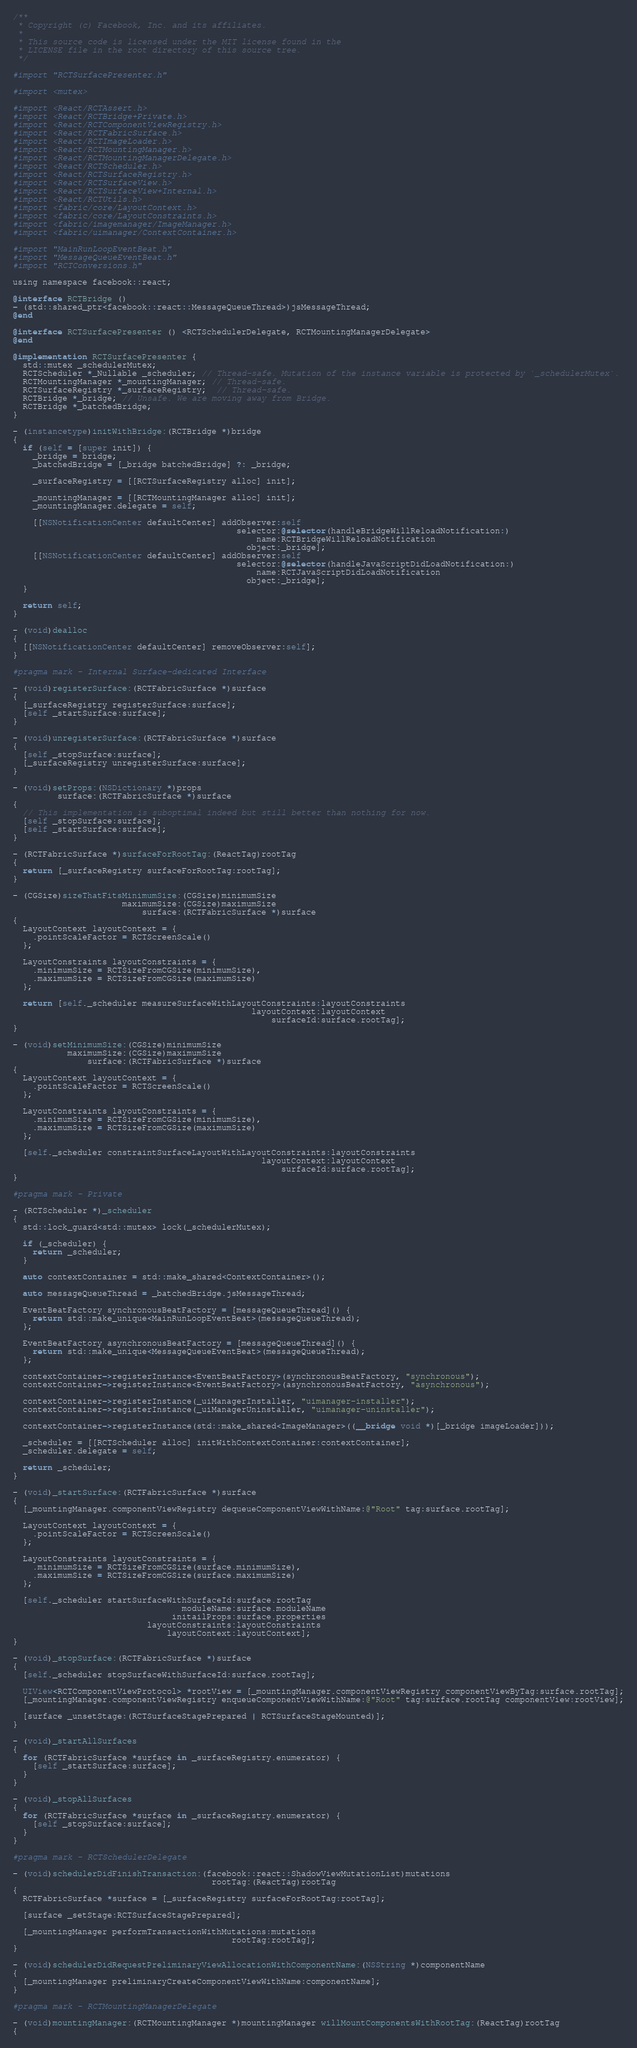Convert code to text. <code><loc_0><loc_0><loc_500><loc_500><_ObjectiveC_>/**
 * Copyright (c) Facebook, Inc. and its affiliates.
 *
 * This source code is licensed under the MIT license found in the
 * LICENSE file in the root directory of this source tree.
 */

#import "RCTSurfacePresenter.h"

#import <mutex>

#import <React/RCTAssert.h>
#import <React/RCTBridge+Private.h>
#import <React/RCTComponentViewRegistry.h>
#import <React/RCTFabricSurface.h>
#import <React/RCTImageLoader.h>
#import <React/RCTMountingManager.h>
#import <React/RCTMountingManagerDelegate.h>
#import <React/RCTScheduler.h>
#import <React/RCTSurfaceRegistry.h>
#import <React/RCTSurfaceView.h>
#import <React/RCTSurfaceView+Internal.h>
#import <React/RCTUtils.h>
#import <fabric/core/LayoutContext.h>
#import <fabric/core/LayoutConstraints.h>
#import <fabric/imagemanager/ImageManager.h>
#import <fabric/uimanager/ContextContainer.h>

#import "MainRunLoopEventBeat.h"
#import "MessageQueueEventBeat.h"
#import "RCTConversions.h"

using namespace facebook::react;

@interface RCTBridge ()
- (std::shared_ptr<facebook::react::MessageQueueThread>)jsMessageThread;
@end

@interface RCTSurfacePresenter () <RCTSchedulerDelegate, RCTMountingManagerDelegate>
@end

@implementation RCTSurfacePresenter {
  std::mutex _schedulerMutex;
  RCTScheduler *_Nullable _scheduler; // Thread-safe. Mutation of the instance variable is protected by `_schedulerMutex`.
  RCTMountingManager *_mountingManager; // Thread-safe.
  RCTSurfaceRegistry *_surfaceRegistry;  // Thread-safe.
  RCTBridge *_bridge; // Unsafe. We are moving away from Bridge.
  RCTBridge *_batchedBridge;
}

- (instancetype)initWithBridge:(RCTBridge *)bridge
{
  if (self = [super init]) {
    _bridge = bridge;
    _batchedBridge = [_bridge batchedBridge] ?: _bridge;

    _surfaceRegistry = [[RCTSurfaceRegistry alloc] init];

    _mountingManager = [[RCTMountingManager alloc] init];
    _mountingManager.delegate = self;

    [[NSNotificationCenter defaultCenter] addObserver:self
                                             selector:@selector(handleBridgeWillReloadNotification:)
                                                 name:RCTBridgeWillReloadNotification
                                               object:_bridge];
    [[NSNotificationCenter defaultCenter] addObserver:self
                                             selector:@selector(handleJavaScriptDidLoadNotification:)
                                                 name:RCTJavaScriptDidLoadNotification
                                               object:_bridge];
  }

  return self;
}

- (void)dealloc
{
  [[NSNotificationCenter defaultCenter] removeObserver:self];
}

#pragma mark - Internal Surface-dedicated Interface

- (void)registerSurface:(RCTFabricSurface *)surface
{
  [_surfaceRegistry registerSurface:surface];
  [self _startSurface:surface];
}

- (void)unregisterSurface:(RCTFabricSurface *)surface
{
  [self _stopSurface:surface];
  [_surfaceRegistry unregisterSurface:surface];
}

- (void)setProps:(NSDictionary *)props
         surface:(RCTFabricSurface *)surface
{
  // This implementation is suboptimal indeed but still better than nothing for now.
  [self _stopSurface:surface];
  [self _startSurface:surface];
}

- (RCTFabricSurface *)surfaceForRootTag:(ReactTag)rootTag
{
  return [_surfaceRegistry surfaceForRootTag:rootTag];
}

- (CGSize)sizeThatFitsMinimumSize:(CGSize)minimumSize
                      maximumSize:(CGSize)maximumSize
                          surface:(RCTFabricSurface *)surface
{
  LayoutContext layoutContext = {
    .pointScaleFactor = RCTScreenScale()
  };

  LayoutConstraints layoutConstraints = {
    .minimumSize = RCTSizeFromCGSize(minimumSize),
    .maximumSize = RCTSizeFromCGSize(maximumSize)
  };

  return [self._scheduler measureSurfaceWithLayoutConstraints:layoutConstraints
                                                layoutContext:layoutContext
                                                    surfaceId:surface.rootTag];
}

- (void)setMinimumSize:(CGSize)minimumSize
           maximumSize:(CGSize)maximumSize
               surface:(RCTFabricSurface *)surface
{
  LayoutContext layoutContext = {
    .pointScaleFactor = RCTScreenScale()
  };

  LayoutConstraints layoutConstraints = {
    .minimumSize = RCTSizeFromCGSize(minimumSize),
    .maximumSize = RCTSizeFromCGSize(maximumSize)
  };

  [self._scheduler constraintSurfaceLayoutWithLayoutConstraints:layoutConstraints
                                                  layoutContext:layoutContext
                                                      surfaceId:surface.rootTag];
}

#pragma mark - Private

- (RCTScheduler *)_scheduler
{
  std::lock_guard<std::mutex> lock(_schedulerMutex);

  if (_scheduler) {
    return _scheduler;
  }

  auto contextContainer = std::make_shared<ContextContainer>();

  auto messageQueueThread = _batchedBridge.jsMessageThread;

  EventBeatFactory synchronousBeatFactory = [messageQueueThread]() {
    return std::make_unique<MainRunLoopEventBeat>(messageQueueThread);
  };

  EventBeatFactory asynchronousBeatFactory = [messageQueueThread]() {
    return std::make_unique<MessageQueueEventBeat>(messageQueueThread);
  };

  contextContainer->registerInstance<EventBeatFactory>(synchronousBeatFactory, "synchronous");
  contextContainer->registerInstance<EventBeatFactory>(asynchronousBeatFactory, "asynchronous");

  contextContainer->registerInstance(_uiManagerInstaller, "uimanager-installer");
  contextContainer->registerInstance(_uiManagerUninstaller, "uimanager-uninstaller");

  contextContainer->registerInstance(std::make_shared<ImageManager>((__bridge void *)[_bridge imageLoader]));

  _scheduler = [[RCTScheduler alloc] initWithContextContainer:contextContainer];
  _scheduler.delegate = self;

  return _scheduler;
}

- (void)_startSurface:(RCTFabricSurface *)surface
{
  [_mountingManager.componentViewRegistry dequeueComponentViewWithName:@"Root" tag:surface.rootTag];

  LayoutContext layoutContext = {
    .pointScaleFactor = RCTScreenScale()
  };

  LayoutConstraints layoutConstraints = {
    .minimumSize = RCTSizeFromCGSize(surface.minimumSize),
    .maximumSize = RCTSizeFromCGSize(surface.maximumSize)
  };

  [self._scheduler startSurfaceWithSurfaceId:surface.rootTag
                                  moduleName:surface.moduleName
                                initailProps:surface.properties
                           layoutConstraints:layoutConstraints
                               layoutContext:layoutContext];
}

- (void)_stopSurface:(RCTFabricSurface *)surface
{
  [self._scheduler stopSurfaceWithSurfaceId:surface.rootTag];

  UIView<RCTComponentViewProtocol> *rootView = [_mountingManager.componentViewRegistry componentViewByTag:surface.rootTag];
  [_mountingManager.componentViewRegistry enqueueComponentViewWithName:@"Root" tag:surface.rootTag componentView:rootView];

  [surface _unsetStage:(RCTSurfaceStagePrepared | RCTSurfaceStageMounted)];
}

- (void)_startAllSurfaces
{
  for (RCTFabricSurface *surface in _surfaceRegistry.enumerator) {
    [self _startSurface:surface];
  }
}

- (void)_stopAllSurfaces
{
  for (RCTFabricSurface *surface in _surfaceRegistry.enumerator) {
    [self _stopSurface:surface];
  }
}

#pragma mark - RCTSchedulerDelegate

- (void)schedulerDidFinishTransaction:(facebook::react::ShadowViewMutationList)mutations
                                        rootTag:(ReactTag)rootTag
{
  RCTFabricSurface *surface = [_surfaceRegistry surfaceForRootTag:rootTag];

  [surface _setStage:RCTSurfaceStagePrepared];

  [_mountingManager performTransactionWithMutations:mutations
                                            rootTag:rootTag];
}

- (void)schedulerDidRequestPreliminaryViewAllocationWithComponentName:(NSString *)componentName
{
  [_mountingManager preliminaryCreateComponentViewWithName:componentName];
}

#pragma mark - RCTMountingManagerDelegate

- (void)mountingManager:(RCTMountingManager *)mountingManager willMountComponentsWithRootTag:(ReactTag)rootTag
{</code> 